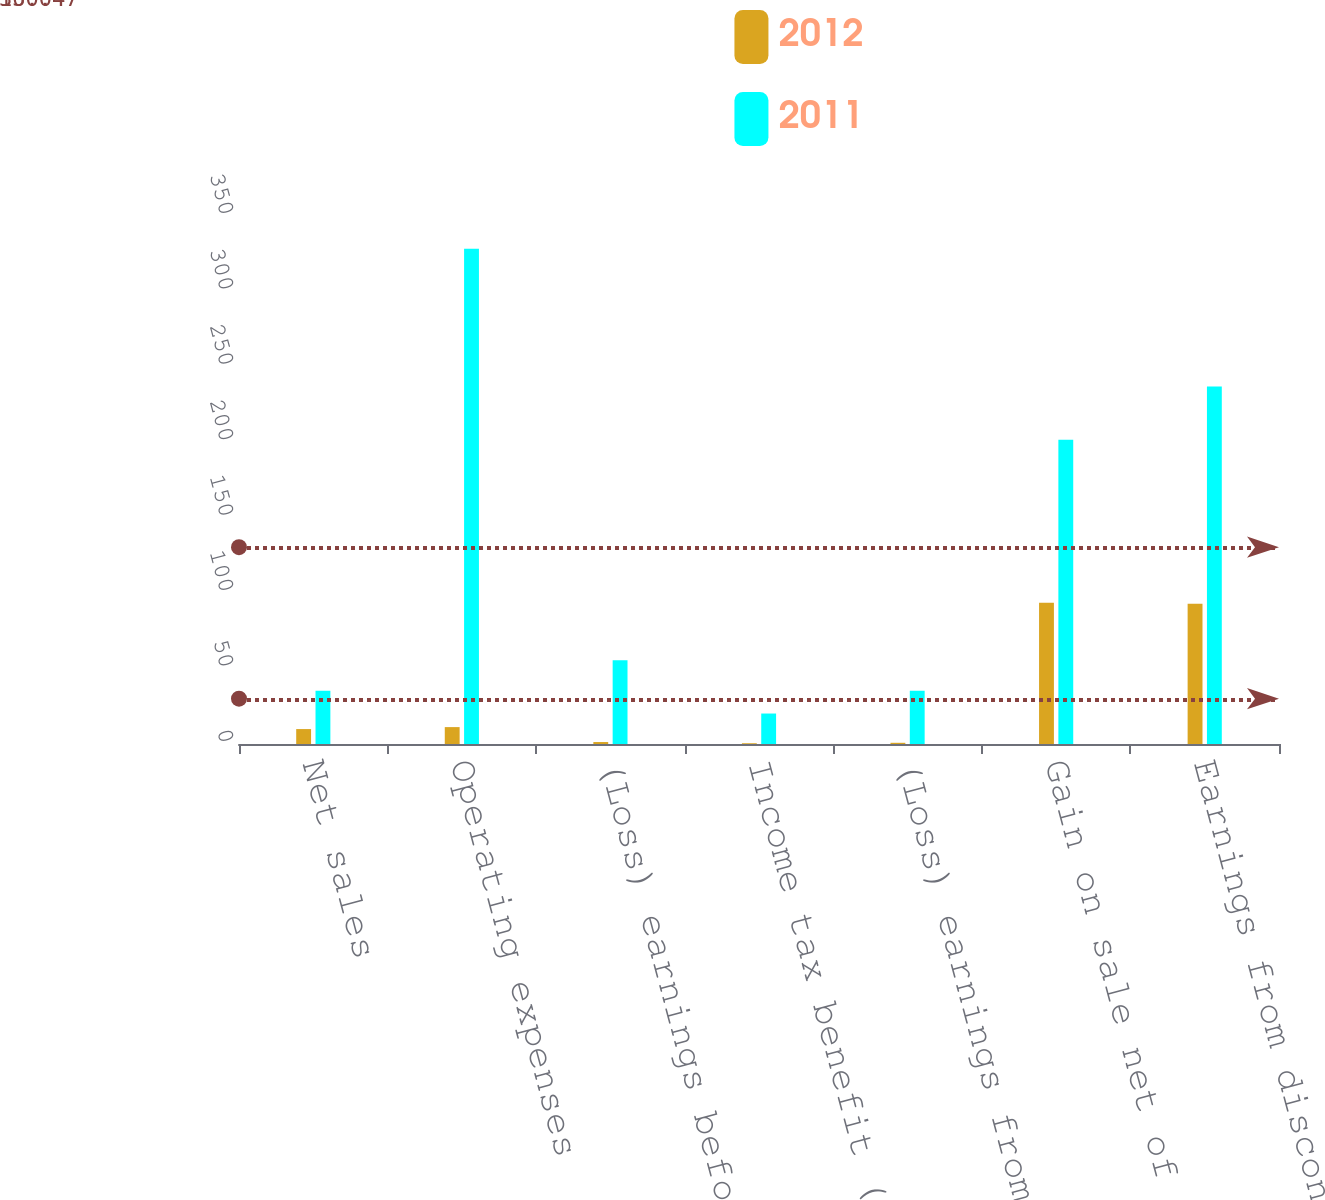Convert chart to OTSL. <chart><loc_0><loc_0><loc_500><loc_500><stacked_bar_chart><ecel><fcel>Net sales<fcel>Operating expenses<fcel>(Loss) earnings before income<fcel>Income tax benefit (expense)<fcel>(Loss) earnings from<fcel>Gain on sale net of 550<fcel>Earnings from discontinued<nl><fcel>2012<fcel>9.9<fcel>11.2<fcel>1.3<fcel>0.5<fcel>0.8<fcel>93.7<fcel>92.9<nl><fcel>2011<fcel>35.3<fcel>328.3<fcel>55.5<fcel>20.2<fcel>35.3<fcel>201.7<fcel>237<nl></chart> 